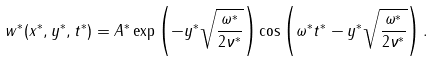<formula> <loc_0><loc_0><loc_500><loc_500>w ^ { * } ( x ^ { * } , y ^ { * } , t ^ { * } ) = A ^ { * } \exp \left ( - y ^ { * } \sqrt { \frac { \omega ^ { * } } { 2 \nu ^ { * } } } \right ) \cos \left ( \omega ^ { * } t ^ { * } - y ^ { * } \sqrt { \frac { \omega ^ { * } } { 2 \nu ^ { * } } } \right ) .</formula> 